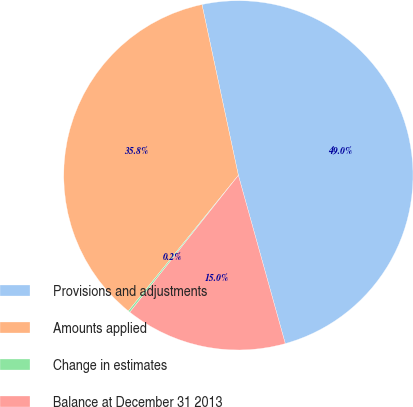Convert chart. <chart><loc_0><loc_0><loc_500><loc_500><pie_chart><fcel>Provisions and adjustments<fcel>Amounts applied<fcel>Change in estimates<fcel>Balance at December 31 2013<nl><fcel>49.02%<fcel>35.82%<fcel>0.17%<fcel>15.0%<nl></chart> 